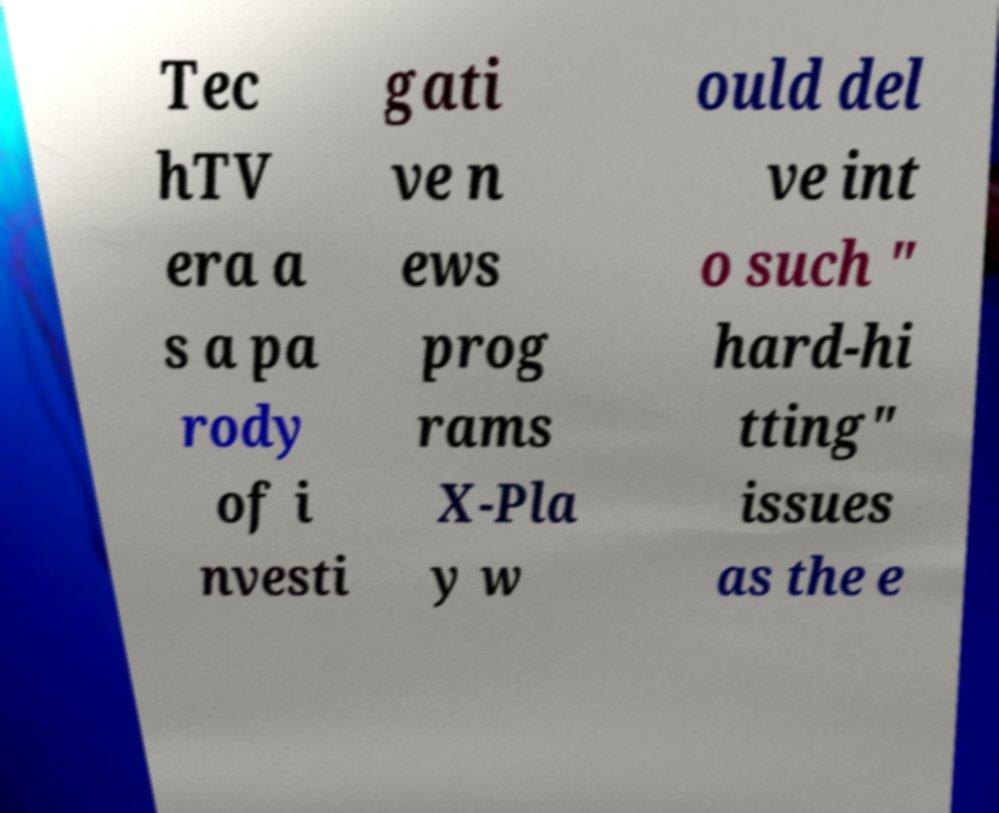I need the written content from this picture converted into text. Can you do that? Tec hTV era a s a pa rody of i nvesti gati ve n ews prog rams X-Pla y w ould del ve int o such " hard-hi tting" issues as the e 